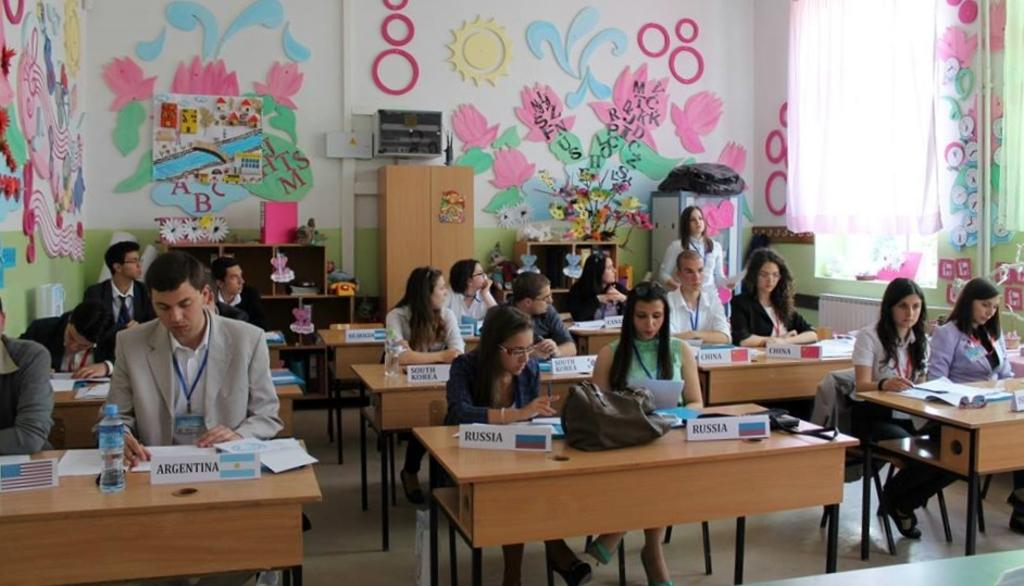What is the color of the wall in the image? The wall in the image is white. What type of furniture is in the image? There are benches in the image. What are the people in the image doing? The people are sitting on the benches. What items can be seen on the benches? Books and posters are present on the benches. What type of string can be seen connecting the books and posters on the benches? There is no string connecting the books and posters on the benches in the image. 